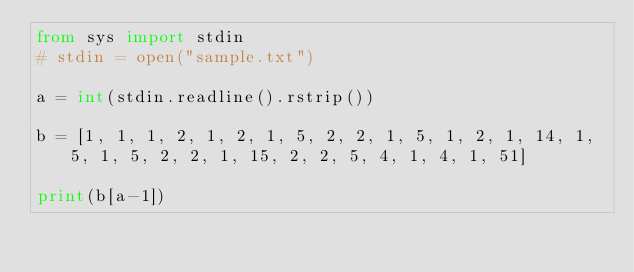Convert code to text. <code><loc_0><loc_0><loc_500><loc_500><_Python_>from sys import stdin
# stdin = open("sample.txt")

a = int(stdin.readline().rstrip())

b = [1, 1, 1, 2, 1, 2, 1, 5, 2, 2, 1, 5, 1, 2, 1, 14, 1, 5, 1, 5, 2, 2, 1, 15, 2, 2, 5, 4, 1, 4, 1, 51]

print(b[a-1])</code> 